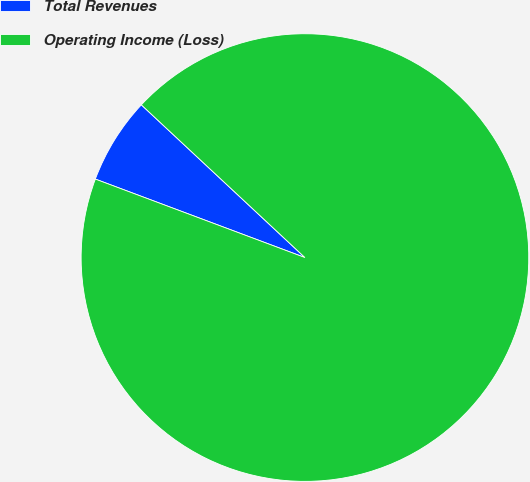Convert chart to OTSL. <chart><loc_0><loc_0><loc_500><loc_500><pie_chart><fcel>Total Revenues<fcel>Operating Income (Loss)<nl><fcel>6.25%<fcel>93.75%<nl></chart> 